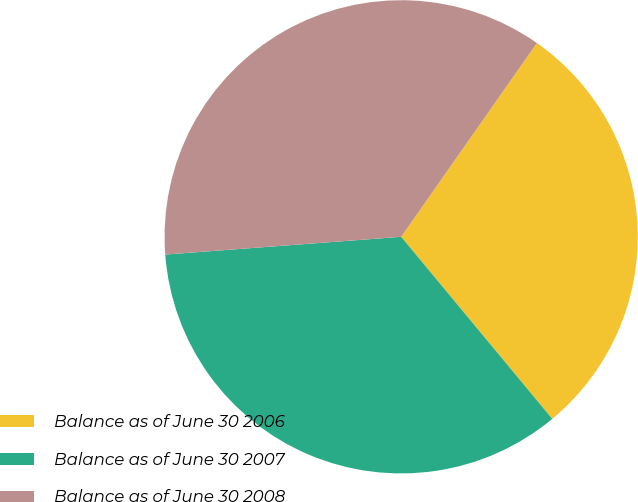<chart> <loc_0><loc_0><loc_500><loc_500><pie_chart><fcel>Balance as of June 30 2006<fcel>Balance as of June 30 2007<fcel>Balance as of June 30 2008<nl><fcel>29.25%<fcel>34.83%<fcel>35.92%<nl></chart> 